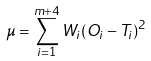Convert formula to latex. <formula><loc_0><loc_0><loc_500><loc_500>\mu = \sum _ { i = 1 } ^ { m + 4 } { W _ { i } ( O _ { i } - T _ { i } ) ^ { 2 } }</formula> 